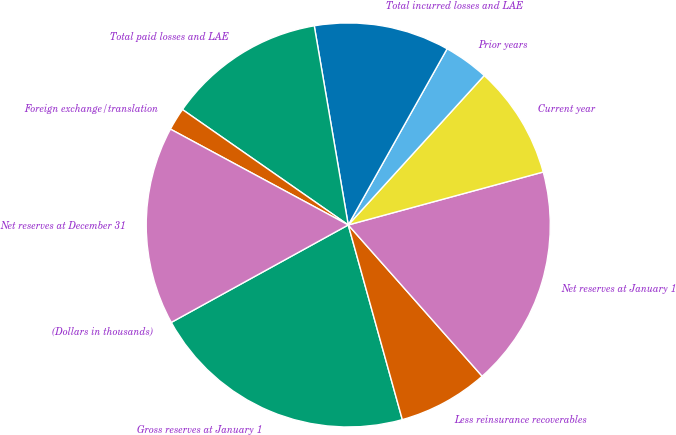Convert chart. <chart><loc_0><loc_0><loc_500><loc_500><pie_chart><fcel>(Dollars in thousands)<fcel>Gross reserves at January 1<fcel>Less reinsurance recoverables<fcel>Net reserves at January 1<fcel>Current year<fcel>Prior years<fcel>Total incurred losses and LAE<fcel>Total paid losses and LAE<fcel>Foreign exchange/translation<fcel>Net reserves at December 31<nl><fcel>0.0%<fcel>21.3%<fcel>7.22%<fcel>17.69%<fcel>9.03%<fcel>3.61%<fcel>10.83%<fcel>12.63%<fcel>1.81%<fcel>15.88%<nl></chart> 